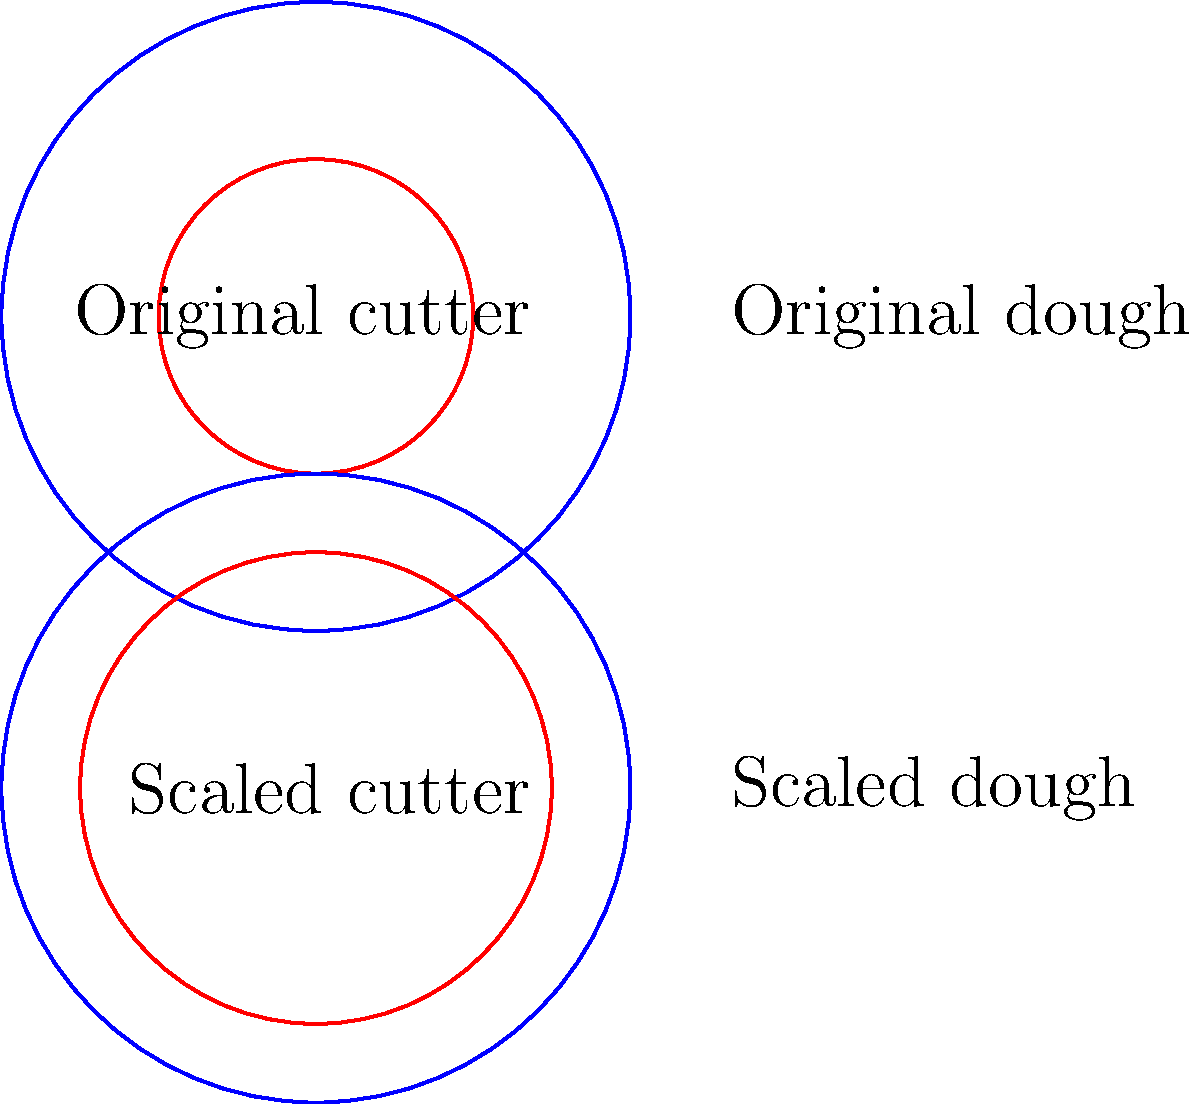You've created a new cookie cutter design for your bakery's signature cookies. The original circular cutter has a diameter of 3 inches and is used for a 6-inch diameter dough circle. You want to scale up your cookie production and now have a 9-inch diameter dough circle. What should be the diameter of the scaled-up cookie cutter to maintain the same proportions as the original design? Let's approach this step-by-step:

1) First, we need to understand the relationship between the original dough and cutter sizes:
   - Original dough diameter: 6 inches
   - Original cutter diameter: 3 inches

2) We can express this as a ratio:
   $\frac{\text{Cutter diameter}}{\text{Dough diameter}} = \frac{3}{6} = \frac{1}{2}$

3) This ratio should remain constant when we scale up the design. Let's call the new cutter diameter $x$:
   $\frac{x}{\text{New dough diameter}} = \frac{1}{2}$

4) We know the new dough diameter is 9 inches, so we can set up the equation:
   $\frac{x}{9} = \frac{1}{2}$

5) To solve for $x$, we can cross-multiply:
   $x = 9 \cdot \frac{1}{2} = \frac{9}{2} = 4.5$

Therefore, the diameter of the scaled-up cookie cutter should be 4.5 inches.
Answer: 4.5 inches 